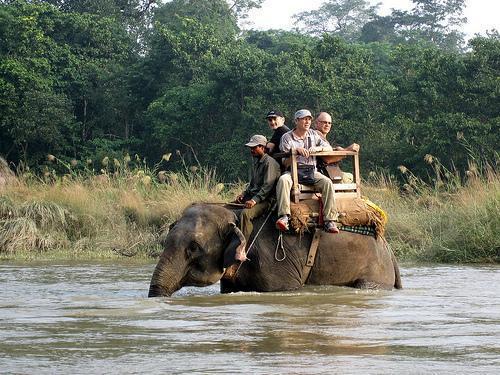How many men are wearing black hats?
Give a very brief answer. 1. 